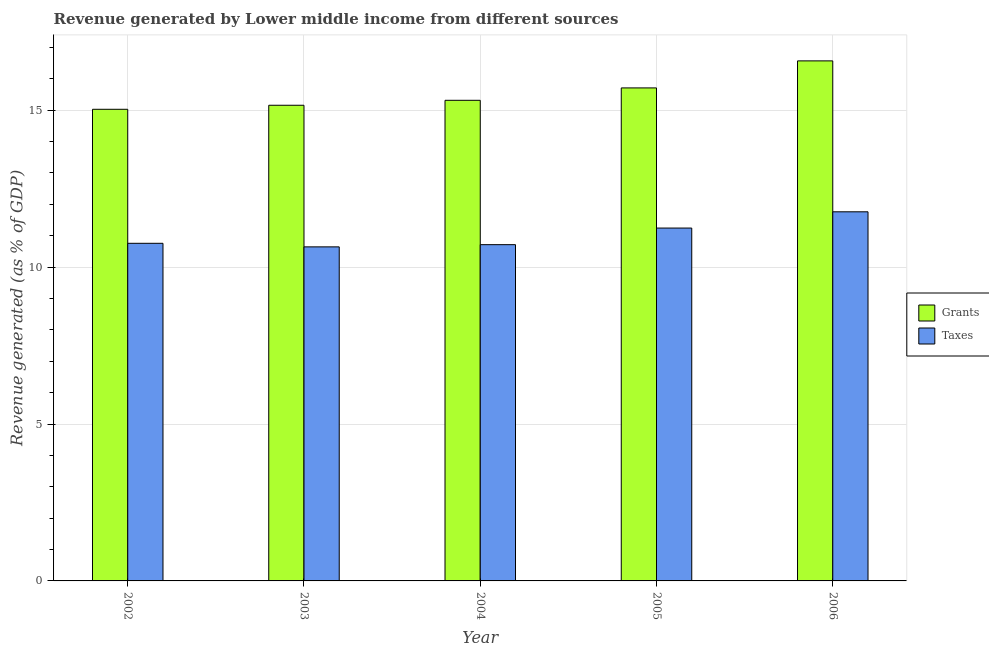How many groups of bars are there?
Offer a very short reply. 5. Are the number of bars per tick equal to the number of legend labels?
Your response must be concise. Yes. What is the label of the 3rd group of bars from the left?
Provide a succinct answer. 2004. In how many cases, is the number of bars for a given year not equal to the number of legend labels?
Make the answer very short. 0. What is the revenue generated by grants in 2005?
Your answer should be compact. 15.71. Across all years, what is the maximum revenue generated by grants?
Your answer should be very brief. 16.57. Across all years, what is the minimum revenue generated by grants?
Provide a short and direct response. 15.03. In which year was the revenue generated by taxes maximum?
Keep it short and to the point. 2006. In which year was the revenue generated by taxes minimum?
Provide a short and direct response. 2003. What is the total revenue generated by taxes in the graph?
Provide a short and direct response. 55.12. What is the difference between the revenue generated by grants in 2004 and that in 2006?
Your answer should be very brief. -1.26. What is the difference between the revenue generated by taxes in 2005 and the revenue generated by grants in 2002?
Ensure brevity in your answer.  0.49. What is the average revenue generated by grants per year?
Your answer should be compact. 15.56. In the year 2005, what is the difference between the revenue generated by taxes and revenue generated by grants?
Give a very brief answer. 0. In how many years, is the revenue generated by grants greater than 3 %?
Offer a very short reply. 5. What is the ratio of the revenue generated by taxes in 2004 to that in 2006?
Offer a very short reply. 0.91. Is the difference between the revenue generated by grants in 2002 and 2004 greater than the difference between the revenue generated by taxes in 2002 and 2004?
Give a very brief answer. No. What is the difference between the highest and the second highest revenue generated by taxes?
Your answer should be very brief. 0.52. What is the difference between the highest and the lowest revenue generated by grants?
Provide a short and direct response. 1.54. In how many years, is the revenue generated by taxes greater than the average revenue generated by taxes taken over all years?
Your response must be concise. 2. What does the 1st bar from the left in 2002 represents?
Your answer should be very brief. Grants. What does the 2nd bar from the right in 2004 represents?
Give a very brief answer. Grants. How many bars are there?
Offer a very short reply. 10. Are the values on the major ticks of Y-axis written in scientific E-notation?
Keep it short and to the point. No. Does the graph contain any zero values?
Offer a terse response. No. Does the graph contain grids?
Keep it short and to the point. Yes. Where does the legend appear in the graph?
Ensure brevity in your answer.  Center right. How many legend labels are there?
Your answer should be very brief. 2. What is the title of the graph?
Give a very brief answer. Revenue generated by Lower middle income from different sources. What is the label or title of the Y-axis?
Ensure brevity in your answer.  Revenue generated (as % of GDP). What is the Revenue generated (as % of GDP) in Grants in 2002?
Your answer should be compact. 15.03. What is the Revenue generated (as % of GDP) of Taxes in 2002?
Provide a short and direct response. 10.76. What is the Revenue generated (as % of GDP) in Grants in 2003?
Your response must be concise. 15.16. What is the Revenue generated (as % of GDP) of Taxes in 2003?
Your answer should be very brief. 10.64. What is the Revenue generated (as % of GDP) of Grants in 2004?
Provide a succinct answer. 15.31. What is the Revenue generated (as % of GDP) in Taxes in 2004?
Your answer should be compact. 10.71. What is the Revenue generated (as % of GDP) in Grants in 2005?
Provide a short and direct response. 15.71. What is the Revenue generated (as % of GDP) of Taxes in 2005?
Provide a short and direct response. 11.24. What is the Revenue generated (as % of GDP) of Grants in 2006?
Ensure brevity in your answer.  16.57. What is the Revenue generated (as % of GDP) of Taxes in 2006?
Offer a terse response. 11.76. Across all years, what is the maximum Revenue generated (as % of GDP) in Grants?
Your answer should be compact. 16.57. Across all years, what is the maximum Revenue generated (as % of GDP) in Taxes?
Make the answer very short. 11.76. Across all years, what is the minimum Revenue generated (as % of GDP) in Grants?
Make the answer very short. 15.03. Across all years, what is the minimum Revenue generated (as % of GDP) of Taxes?
Provide a succinct answer. 10.64. What is the total Revenue generated (as % of GDP) in Grants in the graph?
Offer a very short reply. 77.78. What is the total Revenue generated (as % of GDP) in Taxes in the graph?
Make the answer very short. 55.12. What is the difference between the Revenue generated (as % of GDP) in Grants in 2002 and that in 2003?
Provide a succinct answer. -0.13. What is the difference between the Revenue generated (as % of GDP) of Taxes in 2002 and that in 2003?
Keep it short and to the point. 0.11. What is the difference between the Revenue generated (as % of GDP) in Grants in 2002 and that in 2004?
Your answer should be compact. -0.29. What is the difference between the Revenue generated (as % of GDP) of Taxes in 2002 and that in 2004?
Give a very brief answer. 0.04. What is the difference between the Revenue generated (as % of GDP) in Grants in 2002 and that in 2005?
Provide a succinct answer. -0.68. What is the difference between the Revenue generated (as % of GDP) in Taxes in 2002 and that in 2005?
Your answer should be very brief. -0.49. What is the difference between the Revenue generated (as % of GDP) of Grants in 2002 and that in 2006?
Make the answer very short. -1.54. What is the difference between the Revenue generated (as % of GDP) in Taxes in 2002 and that in 2006?
Offer a terse response. -1. What is the difference between the Revenue generated (as % of GDP) in Grants in 2003 and that in 2004?
Provide a succinct answer. -0.16. What is the difference between the Revenue generated (as % of GDP) in Taxes in 2003 and that in 2004?
Keep it short and to the point. -0.07. What is the difference between the Revenue generated (as % of GDP) in Grants in 2003 and that in 2005?
Give a very brief answer. -0.55. What is the difference between the Revenue generated (as % of GDP) of Taxes in 2003 and that in 2005?
Offer a very short reply. -0.6. What is the difference between the Revenue generated (as % of GDP) of Grants in 2003 and that in 2006?
Your response must be concise. -1.41. What is the difference between the Revenue generated (as % of GDP) of Taxes in 2003 and that in 2006?
Your response must be concise. -1.12. What is the difference between the Revenue generated (as % of GDP) in Grants in 2004 and that in 2005?
Your response must be concise. -0.4. What is the difference between the Revenue generated (as % of GDP) in Taxes in 2004 and that in 2005?
Offer a terse response. -0.53. What is the difference between the Revenue generated (as % of GDP) of Grants in 2004 and that in 2006?
Keep it short and to the point. -1.26. What is the difference between the Revenue generated (as % of GDP) in Taxes in 2004 and that in 2006?
Keep it short and to the point. -1.05. What is the difference between the Revenue generated (as % of GDP) of Grants in 2005 and that in 2006?
Offer a very short reply. -0.86. What is the difference between the Revenue generated (as % of GDP) in Taxes in 2005 and that in 2006?
Make the answer very short. -0.52. What is the difference between the Revenue generated (as % of GDP) in Grants in 2002 and the Revenue generated (as % of GDP) in Taxes in 2003?
Make the answer very short. 4.38. What is the difference between the Revenue generated (as % of GDP) of Grants in 2002 and the Revenue generated (as % of GDP) of Taxes in 2004?
Offer a terse response. 4.31. What is the difference between the Revenue generated (as % of GDP) of Grants in 2002 and the Revenue generated (as % of GDP) of Taxes in 2005?
Your answer should be compact. 3.78. What is the difference between the Revenue generated (as % of GDP) in Grants in 2002 and the Revenue generated (as % of GDP) in Taxes in 2006?
Keep it short and to the point. 3.27. What is the difference between the Revenue generated (as % of GDP) of Grants in 2003 and the Revenue generated (as % of GDP) of Taxes in 2004?
Provide a succinct answer. 4.44. What is the difference between the Revenue generated (as % of GDP) of Grants in 2003 and the Revenue generated (as % of GDP) of Taxes in 2005?
Offer a terse response. 3.91. What is the difference between the Revenue generated (as % of GDP) in Grants in 2003 and the Revenue generated (as % of GDP) in Taxes in 2006?
Your answer should be very brief. 3.39. What is the difference between the Revenue generated (as % of GDP) of Grants in 2004 and the Revenue generated (as % of GDP) of Taxes in 2005?
Make the answer very short. 4.07. What is the difference between the Revenue generated (as % of GDP) in Grants in 2004 and the Revenue generated (as % of GDP) in Taxes in 2006?
Give a very brief answer. 3.55. What is the difference between the Revenue generated (as % of GDP) of Grants in 2005 and the Revenue generated (as % of GDP) of Taxes in 2006?
Offer a terse response. 3.95. What is the average Revenue generated (as % of GDP) of Grants per year?
Make the answer very short. 15.56. What is the average Revenue generated (as % of GDP) in Taxes per year?
Ensure brevity in your answer.  11.02. In the year 2002, what is the difference between the Revenue generated (as % of GDP) of Grants and Revenue generated (as % of GDP) of Taxes?
Ensure brevity in your answer.  4.27. In the year 2003, what is the difference between the Revenue generated (as % of GDP) in Grants and Revenue generated (as % of GDP) in Taxes?
Ensure brevity in your answer.  4.51. In the year 2004, what is the difference between the Revenue generated (as % of GDP) in Grants and Revenue generated (as % of GDP) in Taxes?
Your response must be concise. 4.6. In the year 2005, what is the difference between the Revenue generated (as % of GDP) in Grants and Revenue generated (as % of GDP) in Taxes?
Give a very brief answer. 4.47. In the year 2006, what is the difference between the Revenue generated (as % of GDP) of Grants and Revenue generated (as % of GDP) of Taxes?
Make the answer very short. 4.81. What is the ratio of the Revenue generated (as % of GDP) of Taxes in 2002 to that in 2003?
Provide a short and direct response. 1.01. What is the ratio of the Revenue generated (as % of GDP) of Grants in 2002 to that in 2004?
Your answer should be compact. 0.98. What is the ratio of the Revenue generated (as % of GDP) in Grants in 2002 to that in 2005?
Make the answer very short. 0.96. What is the ratio of the Revenue generated (as % of GDP) in Taxes in 2002 to that in 2005?
Keep it short and to the point. 0.96. What is the ratio of the Revenue generated (as % of GDP) in Grants in 2002 to that in 2006?
Offer a very short reply. 0.91. What is the ratio of the Revenue generated (as % of GDP) of Taxes in 2002 to that in 2006?
Your answer should be very brief. 0.91. What is the ratio of the Revenue generated (as % of GDP) in Grants in 2003 to that in 2004?
Your answer should be very brief. 0.99. What is the ratio of the Revenue generated (as % of GDP) in Taxes in 2003 to that in 2004?
Offer a very short reply. 0.99. What is the ratio of the Revenue generated (as % of GDP) of Grants in 2003 to that in 2005?
Offer a very short reply. 0.96. What is the ratio of the Revenue generated (as % of GDP) in Taxes in 2003 to that in 2005?
Provide a short and direct response. 0.95. What is the ratio of the Revenue generated (as % of GDP) of Grants in 2003 to that in 2006?
Make the answer very short. 0.91. What is the ratio of the Revenue generated (as % of GDP) of Taxes in 2003 to that in 2006?
Keep it short and to the point. 0.91. What is the ratio of the Revenue generated (as % of GDP) of Grants in 2004 to that in 2005?
Keep it short and to the point. 0.97. What is the ratio of the Revenue generated (as % of GDP) in Taxes in 2004 to that in 2005?
Offer a terse response. 0.95. What is the ratio of the Revenue generated (as % of GDP) in Grants in 2004 to that in 2006?
Your answer should be compact. 0.92. What is the ratio of the Revenue generated (as % of GDP) of Taxes in 2004 to that in 2006?
Ensure brevity in your answer.  0.91. What is the ratio of the Revenue generated (as % of GDP) in Grants in 2005 to that in 2006?
Provide a succinct answer. 0.95. What is the ratio of the Revenue generated (as % of GDP) in Taxes in 2005 to that in 2006?
Provide a succinct answer. 0.96. What is the difference between the highest and the second highest Revenue generated (as % of GDP) of Grants?
Ensure brevity in your answer.  0.86. What is the difference between the highest and the second highest Revenue generated (as % of GDP) in Taxes?
Offer a terse response. 0.52. What is the difference between the highest and the lowest Revenue generated (as % of GDP) in Grants?
Provide a short and direct response. 1.54. What is the difference between the highest and the lowest Revenue generated (as % of GDP) of Taxes?
Offer a very short reply. 1.12. 